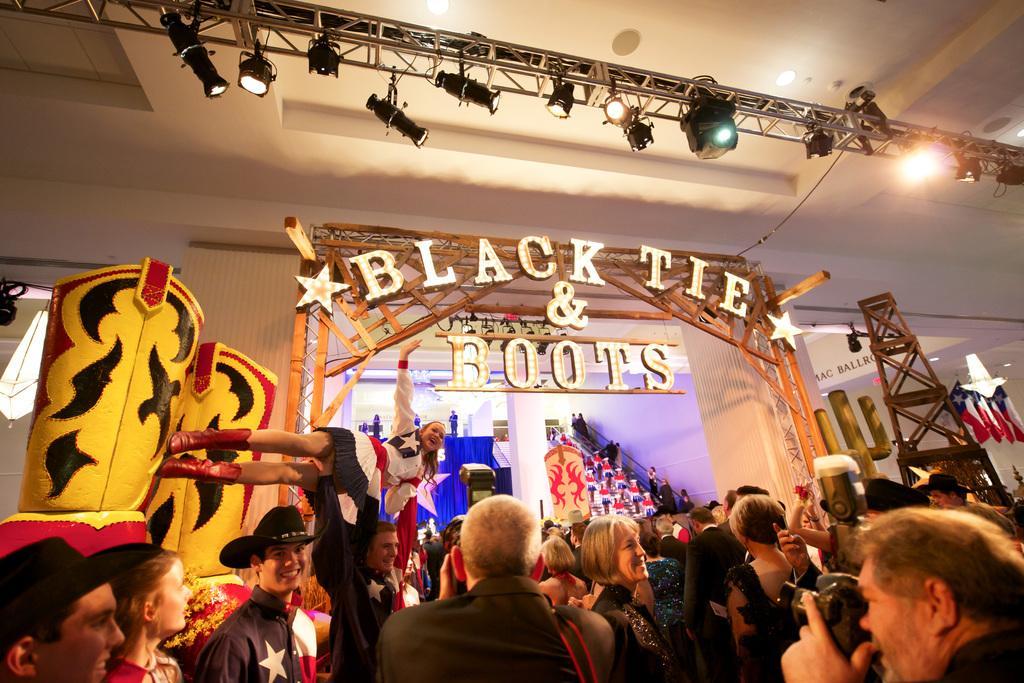Can you describe this image briefly? In this image we can see people, lights, ceiling, pillars, wall, flags, board, and other objects. 